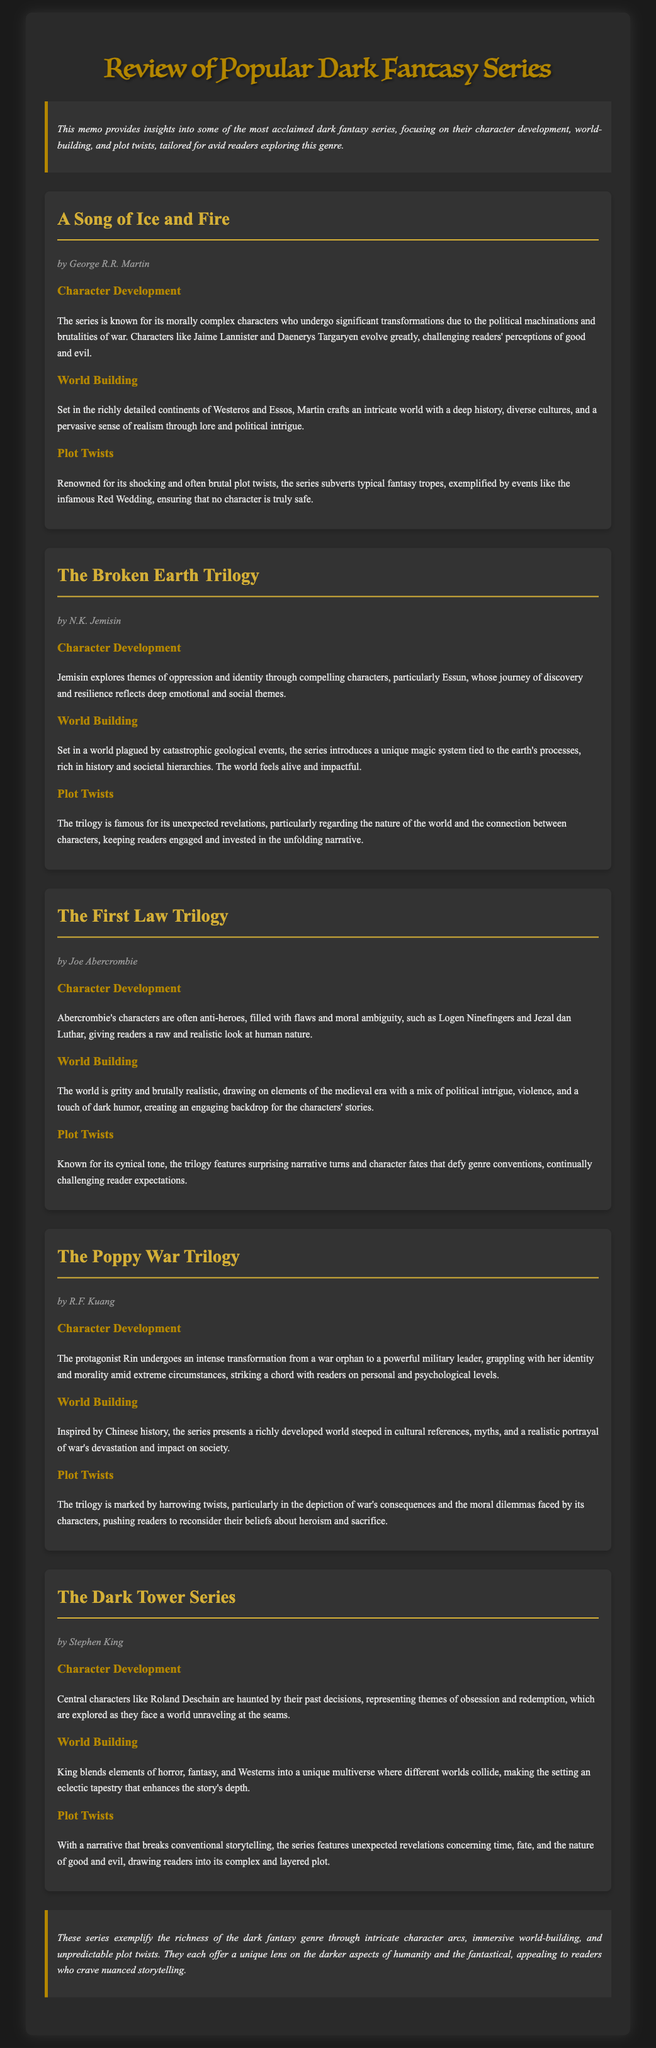What is the title of the memo? The title of the memo can be found at the top of the document, prominently displayed.
Answer: Review of Popular Dark Fantasy Series Who is the author of "A Song of Ice and Fire"? The author's name is stated beneath the title of the series in the document.
Answer: George R.R. Martin What series is known for its morally complex characters? The memo mentions specific characteristics of series that highlight character complexities.
Answer: A Song of Ice and Fire Which author wrote "The Broken Earth Trilogy"? The author’s name is provided with the respective series, indicating authorship clearly in the document.
Answer: N.K. Jemisin How many series are discussed in the memo? The total number of series can be counted based on the distinct sections presented.
Answer: Five What theme does "The Poppy War Trilogy" particularly explore through its protagonist? The memo describes the protagonist's journey, indicating a significant theme central to the series.
Answer: Identity and morality What is a notable plot twist mentioned in "A Song of Ice and Fire"? The memo provides specific events that are highlighted as significant plot twists within the series.
Answer: The Red Wedding How does "The First Law Trilogy" characterize its protagonists? The description of characters reflects their traits, which can be derived from the document's analysis.
Answer: Anti-heroes What unique element is highlighted in the world-building of "The Broken Earth Trilogy"? The memo specifies aspects of the world that contribute to its unique characteristics.
Answer: Unique magic system tied to earth's processes 